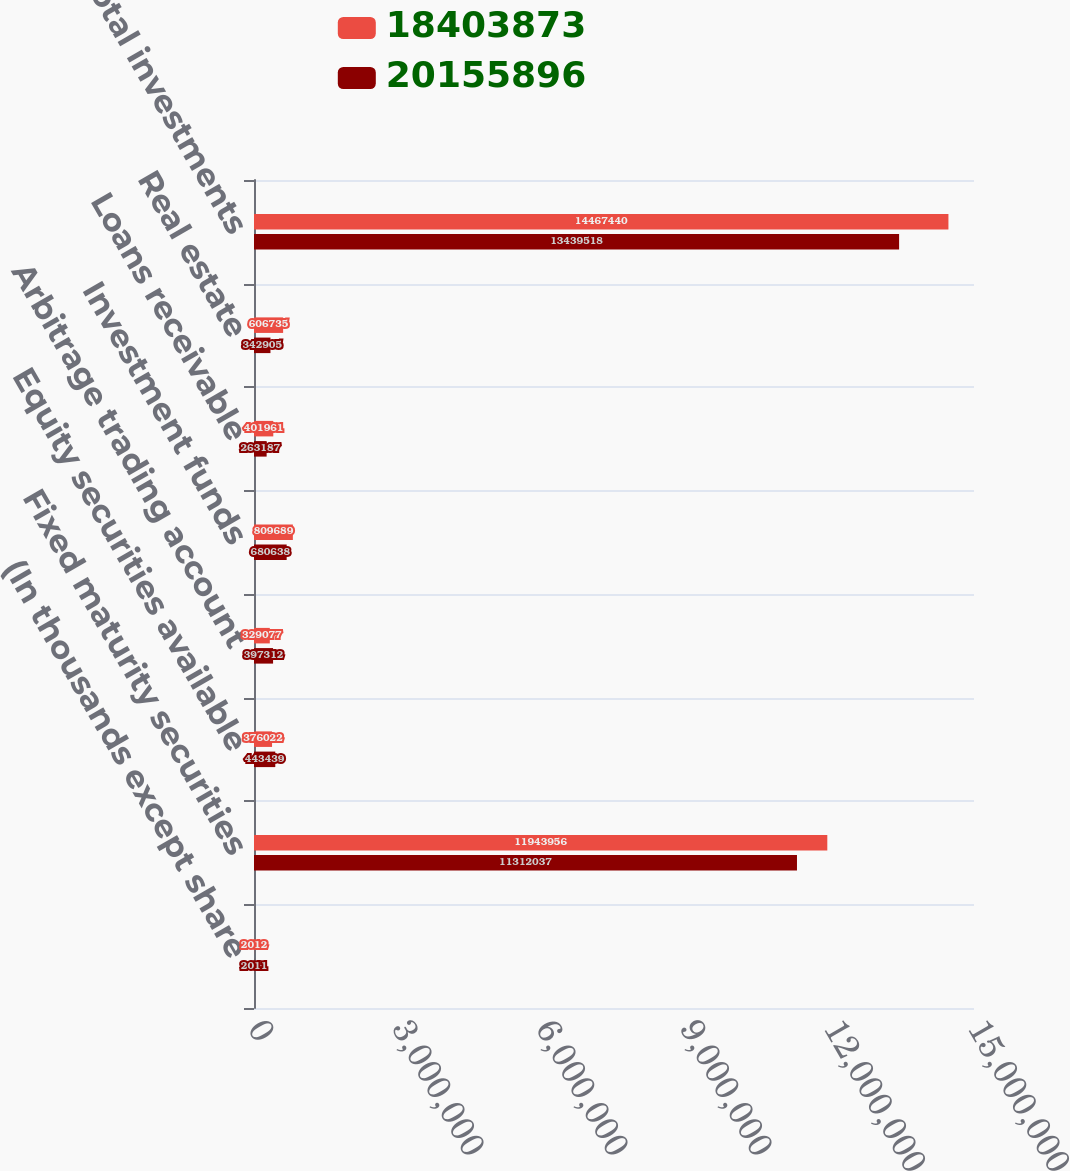Convert chart. <chart><loc_0><loc_0><loc_500><loc_500><stacked_bar_chart><ecel><fcel>(In thousands except share<fcel>Fixed maturity securities<fcel>Equity securities available<fcel>Arbitrage trading account<fcel>Investment funds<fcel>Loans receivable<fcel>Real estate<fcel>Total investments<nl><fcel>1.84039e+07<fcel>2012<fcel>1.1944e+07<fcel>376022<fcel>329077<fcel>809689<fcel>401961<fcel>606735<fcel>1.44674e+07<nl><fcel>2.01559e+07<fcel>2011<fcel>1.1312e+07<fcel>443439<fcel>397312<fcel>680638<fcel>263187<fcel>342905<fcel>1.34395e+07<nl></chart> 